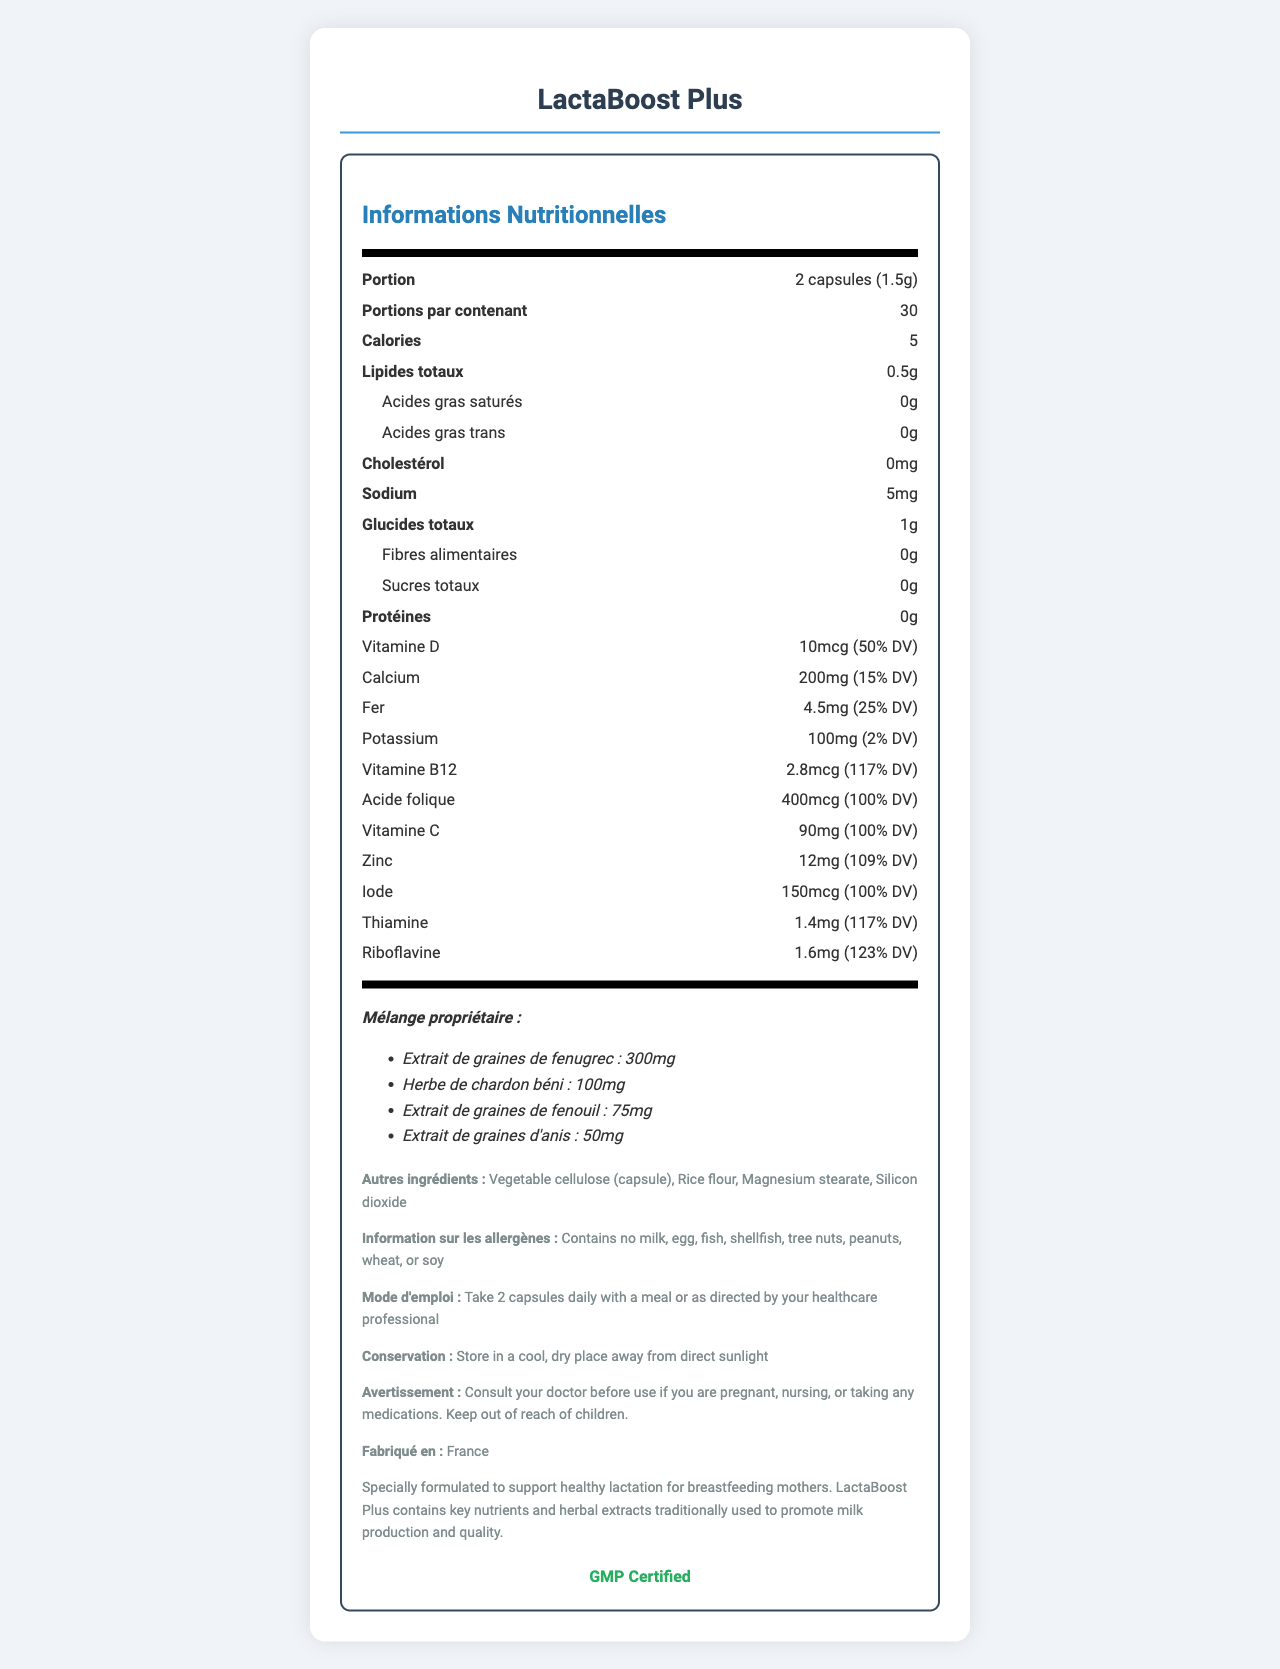what is the serving size of LactaBoost Plus? The serving size is listed at the beginning of the document under the portion-info section.
Answer: 2 capsules (1.5g) how many servings are there in one container? It is mentioned right after the serving size information in the doc.
Answer: 30 what are the main ingredients of the proprietary blend? These ingredients are highlighted in the "Mélange propriétaire" section.
Answer: Fenugreek seed extract, Blessed thistle herb, Fennel seed extract, Anise seed extract how much folic acid is there per serving? This information is provided in the nutritional facts section under folic acid.
Answer: 400mcg (100% DV) how much calcium is contained per serving and what percentage of daily value does it represent? This information can be found in the nutritional facts section under calcium.
Answer: 200mg (15% DV) what are the additional ingredients listed in LactaBoost Plus? These ingredients are enumerated in the "Autres ingrédients" section.
Answer: Vegetable cellulose (capsule), Rice flour, Magnesium stearate, Silicon dioxide how should LactaBoost Plus be stored? Storage instructions are explicitly mentioned in the "Conservation" section.
Answer: Store in a cool, dry place away from direct sunlight which mineral has the highest percentage of daily value (DV) in LactaBoost Plus? A. Calcium B. Iron C. Potassium D. Zinc Zinc has a DV percentage of 109%, which is higher than the other mentioned minerals.
Answer: D. Zinc what is the caloric value per serving? A. 0 calories B. 5 calories C. 10 calories D. 15 calories The caloric value per serving is mentioned directly in the nutritional facts section.
Answer: B. 5 calories is there any cholesterol in the LactaBoost Plus capsules? The nutritional facts section clearly states that there is 0mg of cholesterol per serving.
Answer: No is this product suitable for someone with a soy allergy? The allergen information specifies that it contains no milk, egg, fish, shellfish, tree nuts, peanuts, wheat, or soy.
Answer: Yes summarize the main purpose of LactaBoost Plus. The additional info section highlights the main idea of the product's purpose.
Answer: Supports healthy lactation for breastfeeding mothers with key nutrients and herbal extracts what are the laboratory validation criteria for this product? The document does not provide any specific laboratory validation criteria beyond stating that it is GMP certified.
Answer: Not enough information 